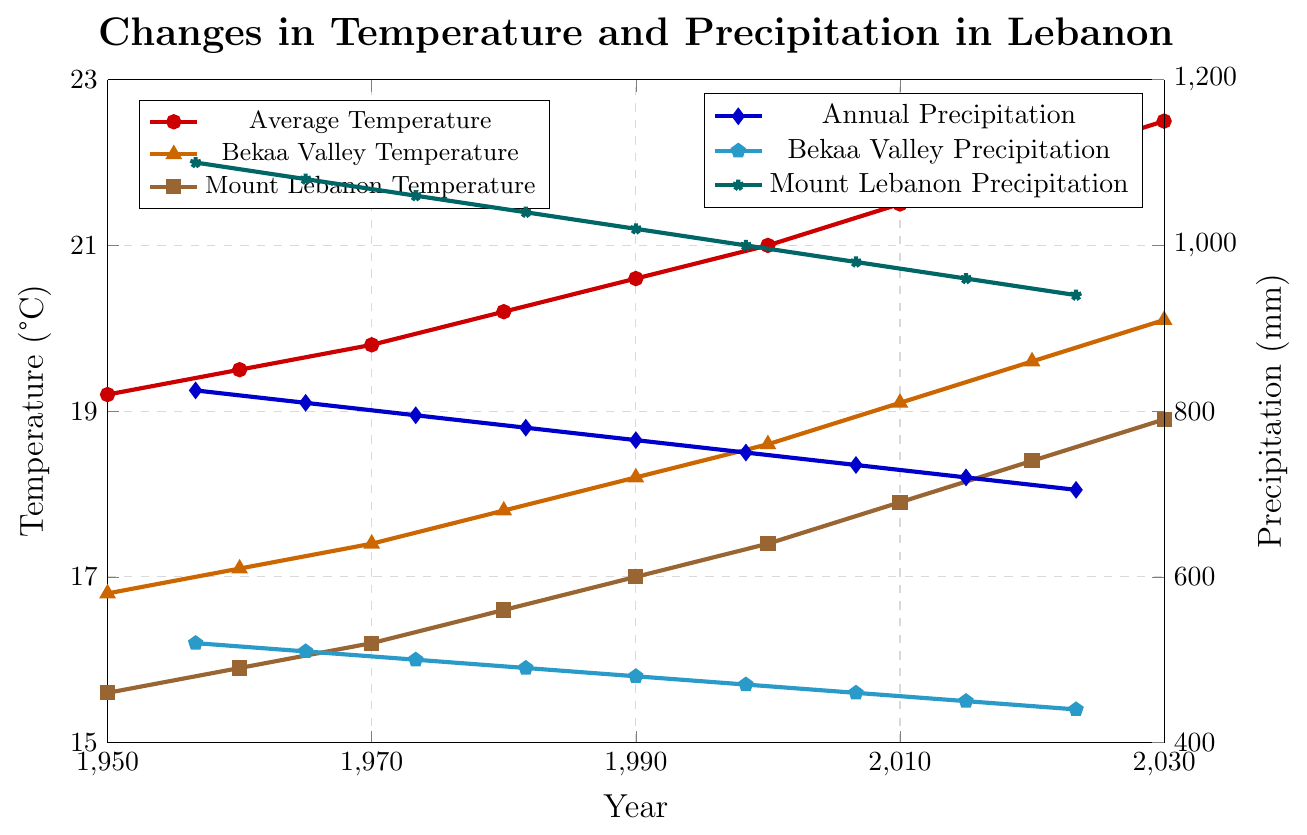What is the overall trend in the average temperature in Lebanon from 1950 to 2030? The line representing average temperature shows a consistent upward trend from 19.2°C in 1950 to 22.5°C in 2030.
Answer: Increasing How much did the Bekaa Valley temperature increase between 1950 and 2030? In 1950, the Bekaa Valley temperature was 16.8°C, and by 2030, it had risen to 20.1°C. The difference is 20.1°C - 16.8°C = 3.3°C.
Answer: 3.3°C Which region experienced a greater increase in temperature, Bekaa Valley or Mount Lebanon? The Bekaa Valley increased from 16.8°C to 20.1°C (3.3°C increase), while Mount Lebanon increased from 15.6°C to 18.9°C (3.3°C increase). Both regions experienced the same increase.
Answer: Both the same What was the trend in annual precipitation in Mount Lebanon from 1950 to 2030? The line for Mount Lebanon's precipitation shows a consistent decrease from 1100 mm in 1950 to 940 mm in 2030.
Answer: Decreasing Was there more precipitation in Bekaa Valley or Mount Lebanon in 1970? In 1970, the Bekaa Valley received 500 mm of precipitation, while Mount Lebanon received 1060 mm. Therefore, Mount Lebanon had more precipitation.
Answer: Mount Lebanon How does the trend in Bekaa Valley precipitation compare to the trend in Bekaa Valley temperature? The Bekaa Valley temperature shows an increasing trend from 16.8°C to 20.1°C, while the precipitation shows a decreasing trend from 520 mm to 440 mm.
Answer: Temperature increases, precipitation decreases What is the difference in average temperature between 1980 and 2020 in Lebanon? In 1980, the average temperature was 20.2°C, while in 2020 it was 22.0°C. The difference is 22.0°C - 20.2°C = 1.8°C.
Answer: 1.8°C Which year had the highest annual precipitation observed in the chart? The highest annual precipitation observed was in 1950 with 825 mm.
Answer: 1950 How much did Bekaa Valley precipitation decrease per decade on average from 1950 to 2030? The decrease from 1950 (520 mm) to 2030 (440 mm) is 520 mm - 440 mm = 80 mm. There are 8 decades between 1950 and 2030. So, 80 mm / 8 = 10 mm per decade.
Answer: 10 mm per decade Compare the temperatures of Bekaa Valley and Mount Lebanon in 1990. In 1990, Bekaa Valley's temperature was 18.2°C, and Mount Lebanon's temperature was 17.0°C. Bekaa Valley was warmer.
Answer: Bekaa Valley warmer 